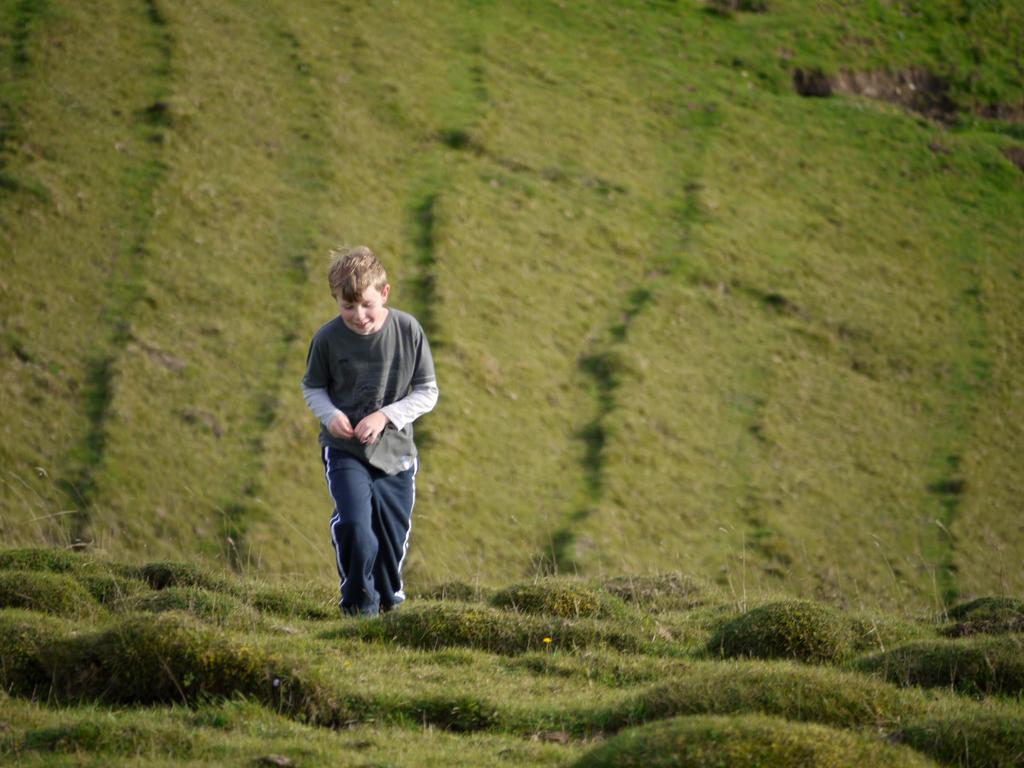What type of vegetation is present at the bottom of the image? A: There is green grass at the bottom of the image. Can you describe the person in the foreground of the image? There is a person in the foreground of the image, but their appearance or actions are not specified. What type of vegetation is present in the background of the image? There is green grass in the background of the image. What grade is the person in the image currently in? There is no information about the person's grade or education level in the image. What day of the week is it in the image? The day of the week is not specified in the image. 